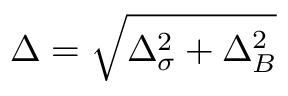<formula> <loc_0><loc_0><loc_500><loc_500>\Delta = \sqrt { \Delta _ { \sigma } ^ { 2 } + \Delta _ { B } ^ { 2 } }</formula> 